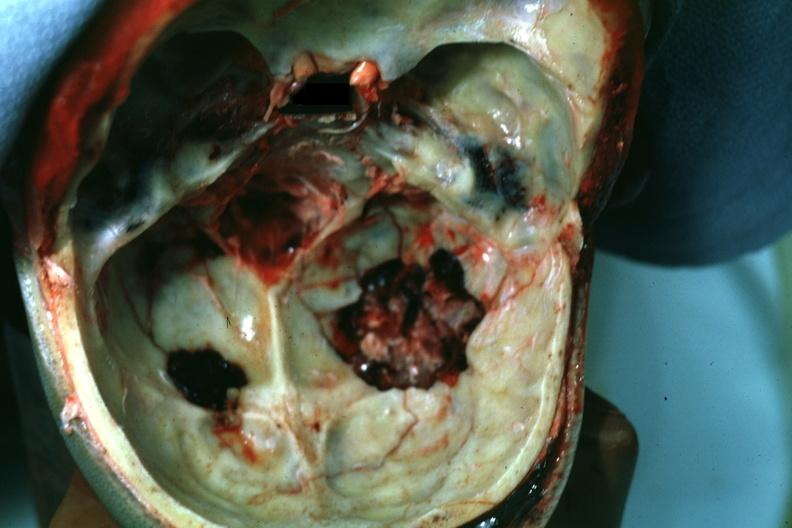what does this look?
Answer the question using a single word or phrase. More like a gunshot wound 